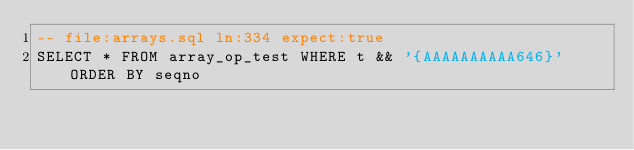Convert code to text. <code><loc_0><loc_0><loc_500><loc_500><_SQL_>-- file:arrays.sql ln:334 expect:true
SELECT * FROM array_op_test WHERE t && '{AAAAAAAAAA646}' ORDER BY seqno
</code> 